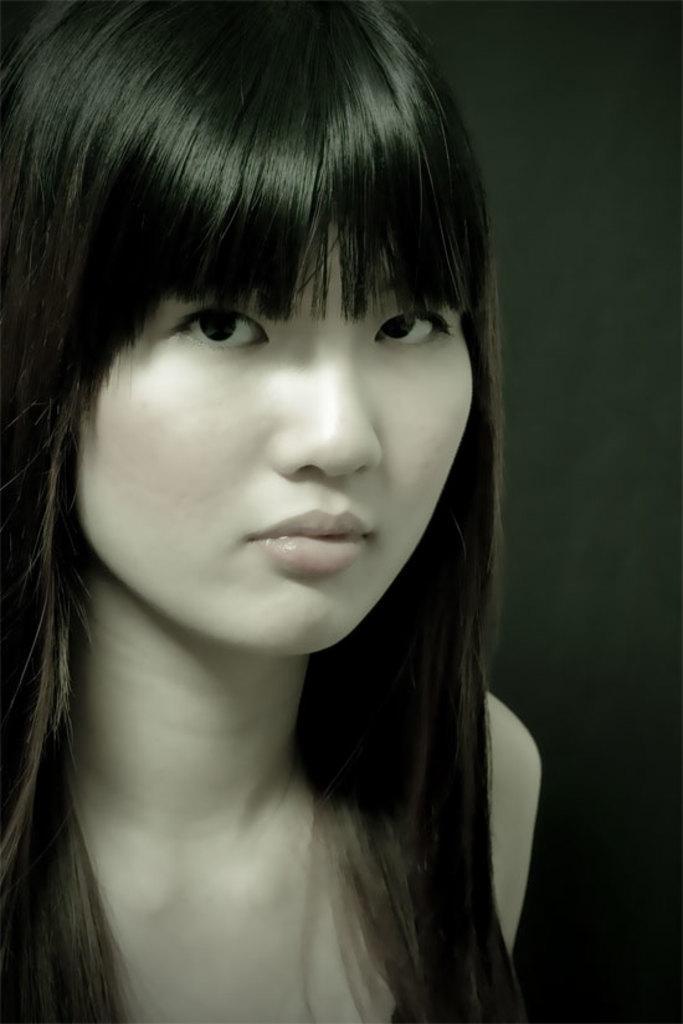How would you summarize this image in a sentence or two? This image consists of a girl. The background is in black color. 